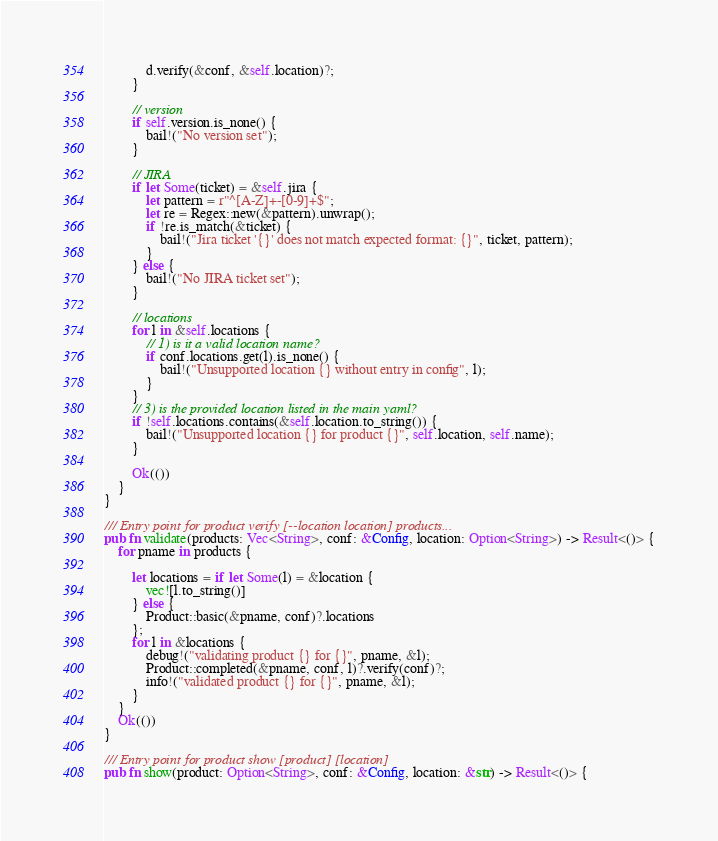<code> <loc_0><loc_0><loc_500><loc_500><_Rust_>            d.verify(&conf, &self.location)?;
        }

        // version
        if self.version.is_none() {
            bail!("No version set");
        }

        // JIRA
        if let Some(ticket) = &self.jira {
            let pattern = r"^[A-Z]+-[0-9]+$";
            let re = Regex::new(&pattern).unwrap();
            if !re.is_match(&ticket) {
                bail!("Jira ticket '{}' does not match expected format: {}", ticket, pattern);
            }
        } else {
            bail!("No JIRA ticket set");
        }

        // locations
        for l in &self.locations {
            // 1) is it a valid location name?
            if conf.locations.get(l).is_none() {
                bail!("Unsupported location {} without entry in config", l);
            }
        }
        // 3) is the provided location listed in the main yaml?
        if !self.locations.contains(&self.location.to_string()) {
            bail!("Unsupported location {} for product {}", self.location, self.name);
        }

        Ok(())
    }
}

/// Entry point for product verify [--location location] products...
pub fn validate(products: Vec<String>, conf: &Config, location: Option<String>) -> Result<()> {
    for pname in products {

        let locations = if let Some(l) = &location {
            vec![l.to_string()]
        } else {
            Product::basic(&pname, conf)?.locations
        };
        for l in &locations {
            debug!("validating product {} for {}", pname, &l);
            Product::completed(&pname, conf, l)?.verify(conf)?;
            info!("validated product {} for {}", pname, &l);
        }
    }
    Ok(())
}

/// Entry point for product show [product] [location]
pub fn show(product: Option<String>, conf: &Config, location: &str) -> Result<()> {</code> 